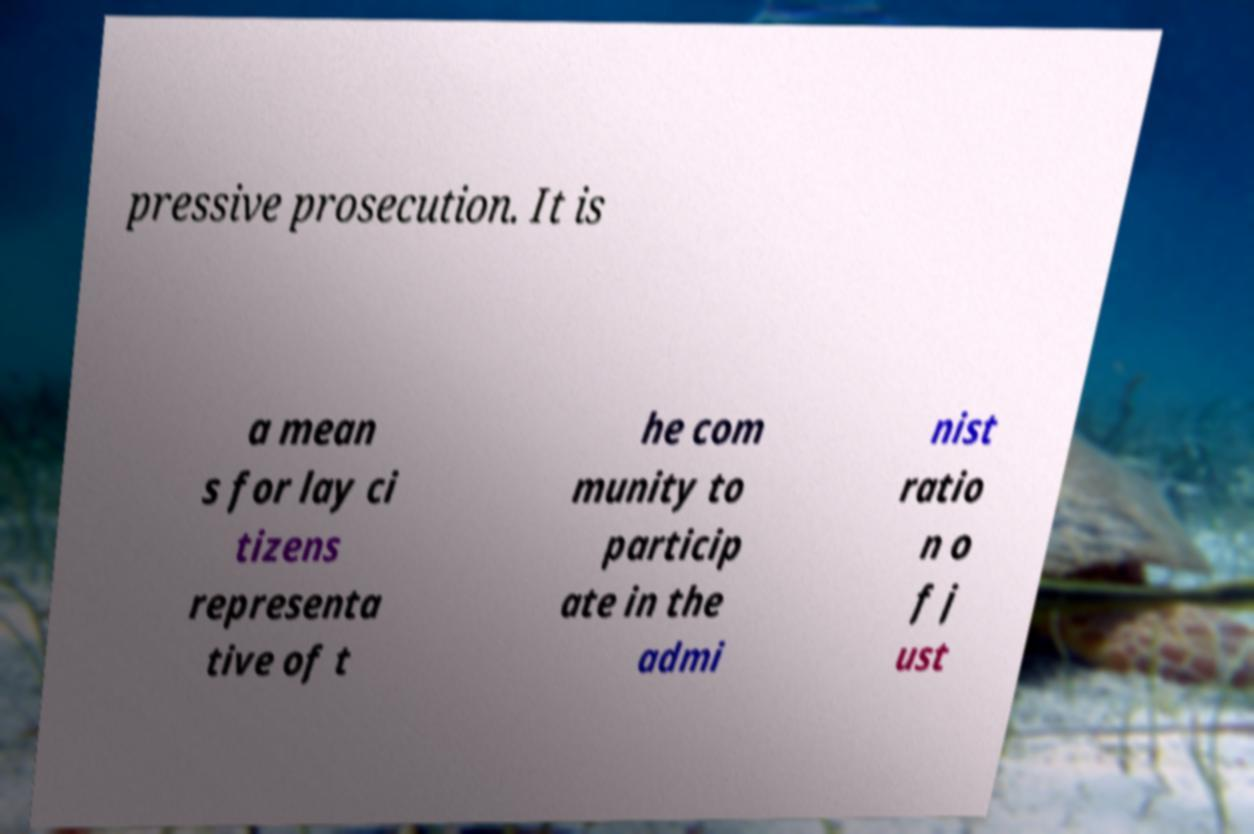Can you read and provide the text displayed in the image?This photo seems to have some interesting text. Can you extract and type it out for me? pressive prosecution. It is a mean s for lay ci tizens representa tive of t he com munity to particip ate in the admi nist ratio n o f j ust 